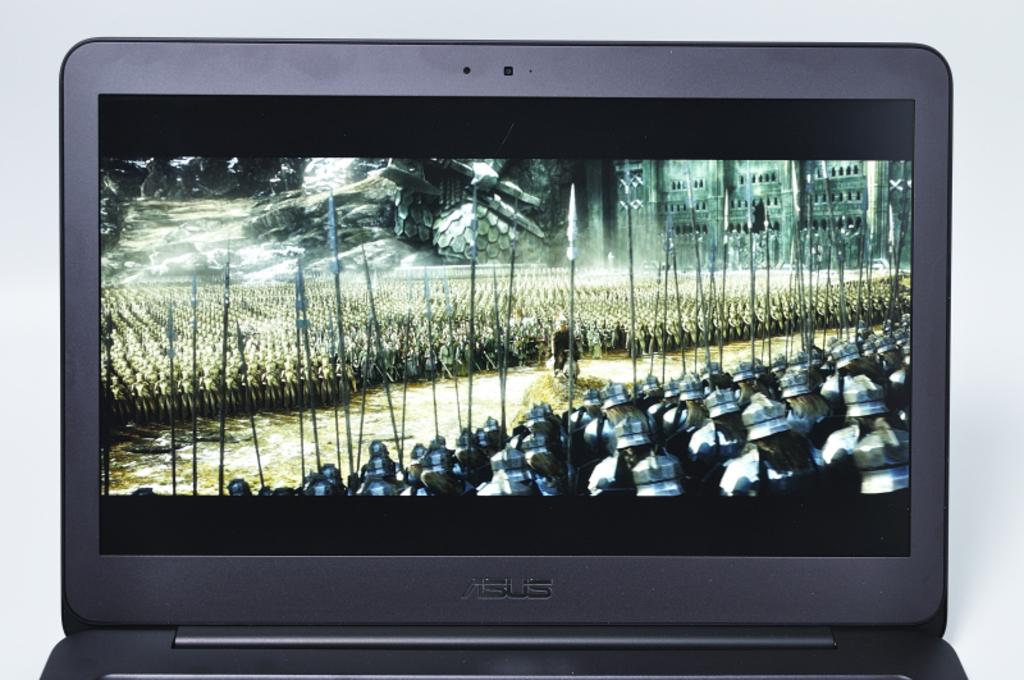<image>
Give a short and clear explanation of the subsequent image. A Visus brand laptop is playing a movie that involves a huge army of soldiers. 